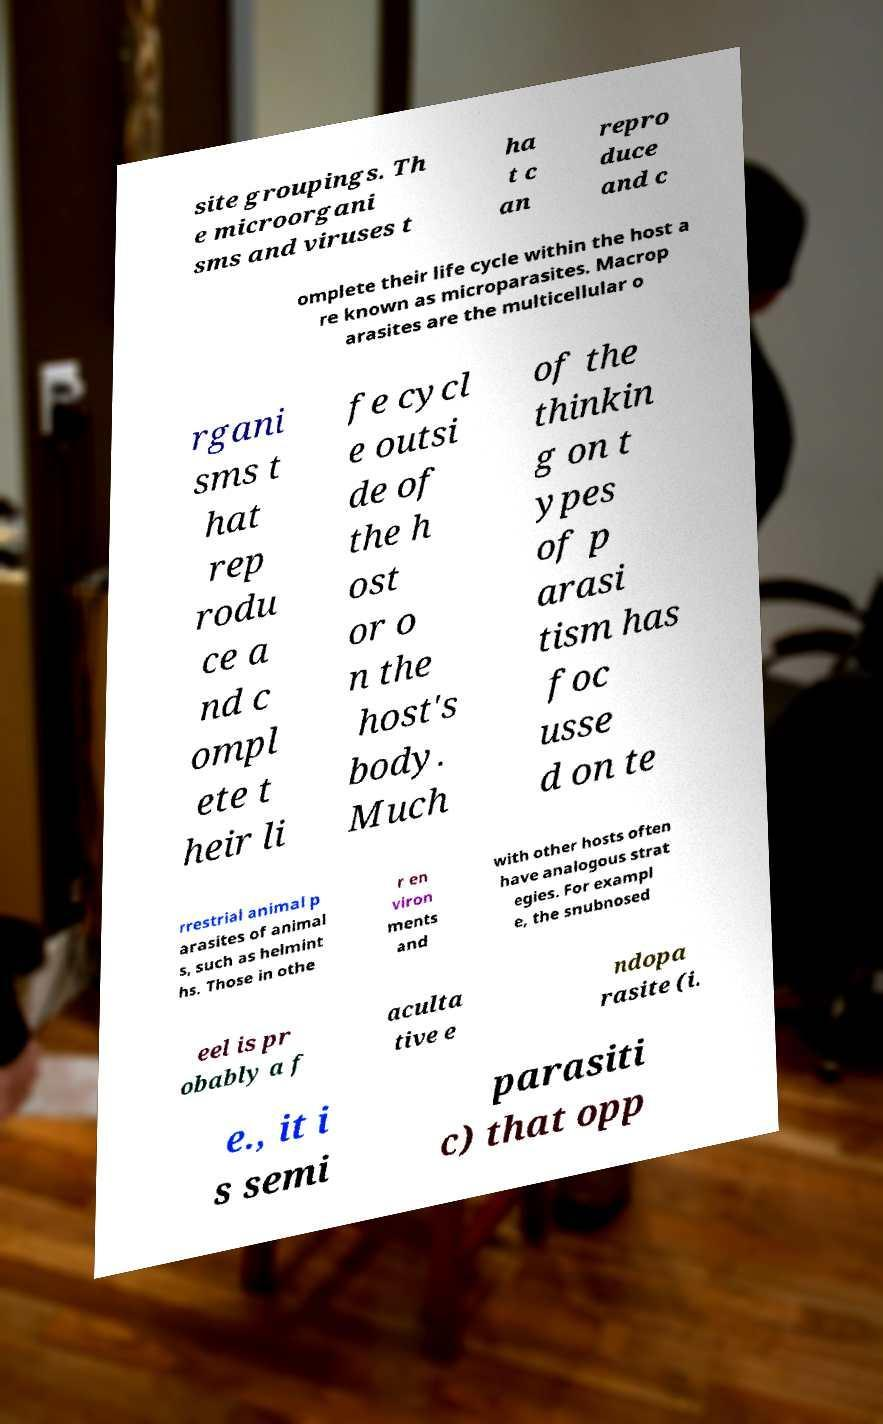I need the written content from this picture converted into text. Can you do that? site groupings. Th e microorgani sms and viruses t ha t c an repro duce and c omplete their life cycle within the host a re known as microparasites. Macrop arasites are the multicellular o rgani sms t hat rep rodu ce a nd c ompl ete t heir li fe cycl e outsi de of the h ost or o n the host's body. Much of the thinkin g on t ypes of p arasi tism has foc usse d on te rrestrial animal p arasites of animal s, such as helmint hs. Those in othe r en viron ments and with other hosts often have analogous strat egies. For exampl e, the snubnosed eel is pr obably a f aculta tive e ndopa rasite (i. e., it i s semi parasiti c) that opp 